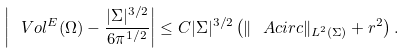<formula> <loc_0><loc_0><loc_500><loc_500>\left | \ V o l ^ { E } ( \Omega ) - \frac { | \Sigma | ^ { 3 / 2 } } { 6 \pi ^ { 1 / 2 } } \right | \leq C | \Sigma | ^ { 3 / 2 } \left ( \| \ A c i r c \| _ { L ^ { 2 } ( \Sigma ) } + r ^ { 2 } \right ) .</formula> 